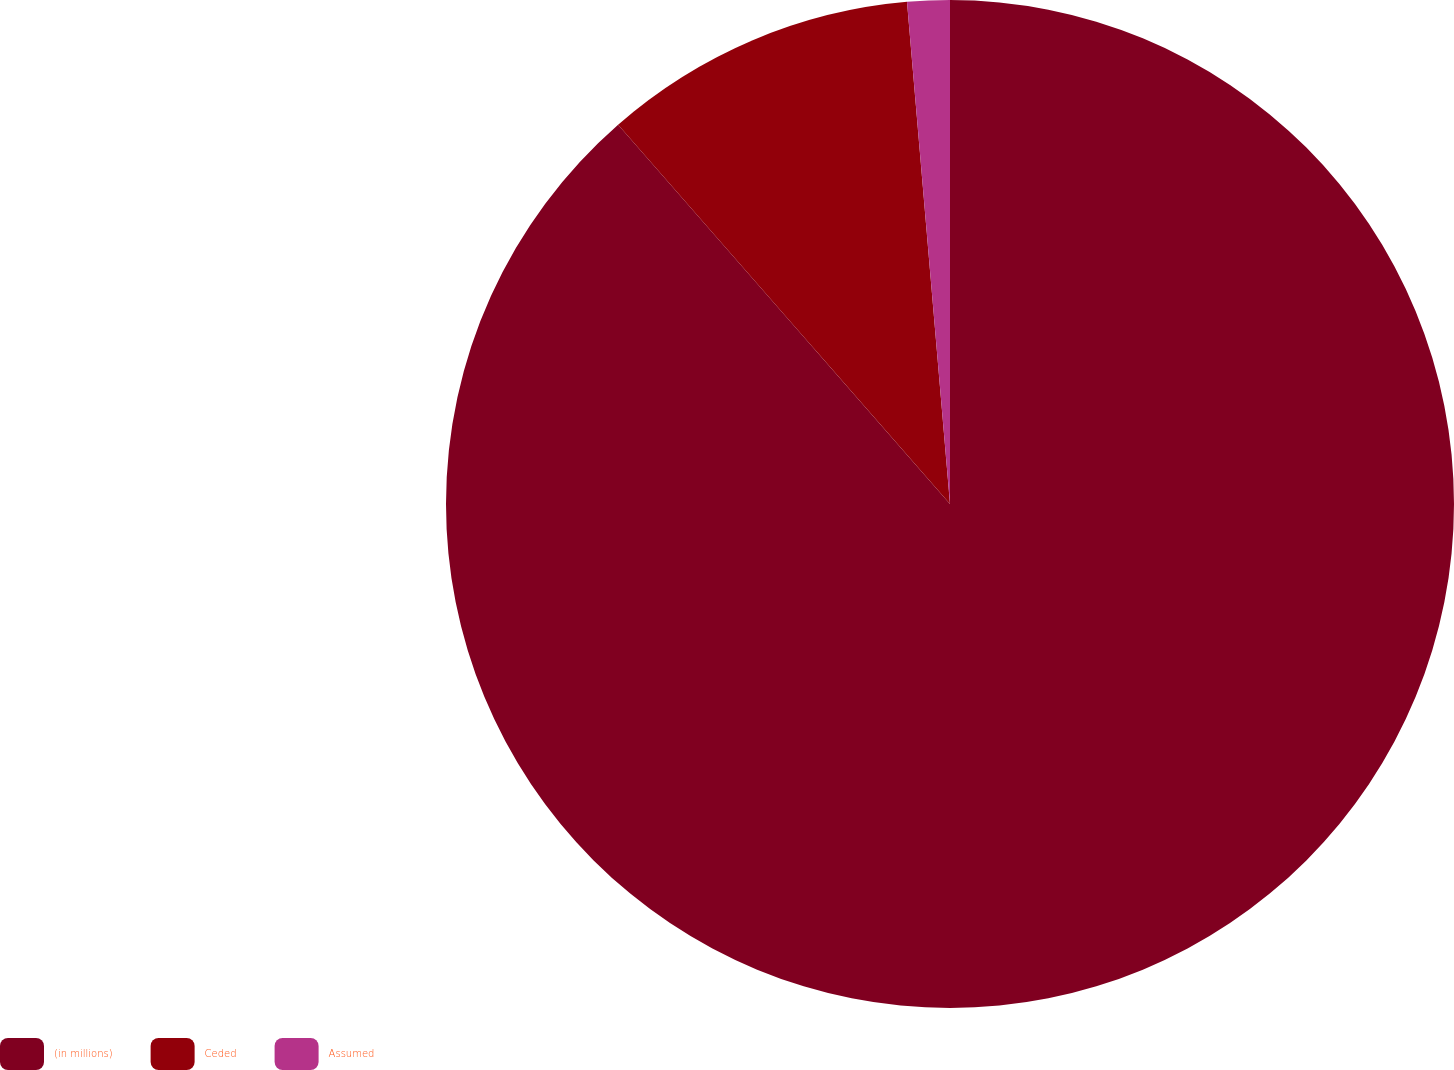<chart> <loc_0><loc_0><loc_500><loc_500><pie_chart><fcel>(in millions)<fcel>Ceded<fcel>Assumed<nl><fcel>88.55%<fcel>10.08%<fcel>1.36%<nl></chart> 